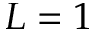Convert formula to latex. <formula><loc_0><loc_0><loc_500><loc_500>L = 1</formula> 